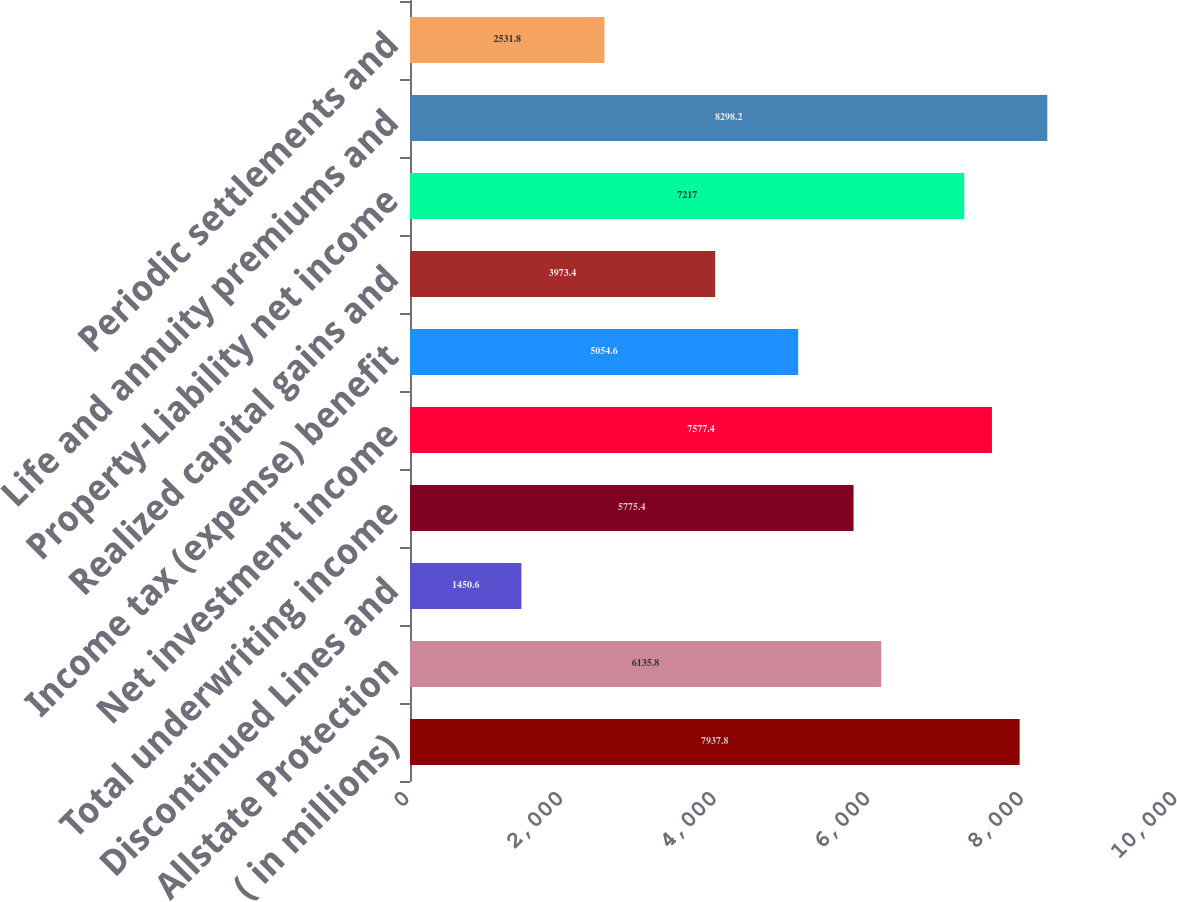<chart> <loc_0><loc_0><loc_500><loc_500><bar_chart><fcel>( in millions)<fcel>Allstate Protection<fcel>Discontinued Lines and<fcel>Total underwriting income<fcel>Net investment income<fcel>Income tax (expense) benefit<fcel>Realized capital gains and<fcel>Property-Liability net income<fcel>Life and annuity premiums and<fcel>Periodic settlements and<nl><fcel>7937.8<fcel>6135.8<fcel>1450.6<fcel>5775.4<fcel>7577.4<fcel>5054.6<fcel>3973.4<fcel>7217<fcel>8298.2<fcel>2531.8<nl></chart> 